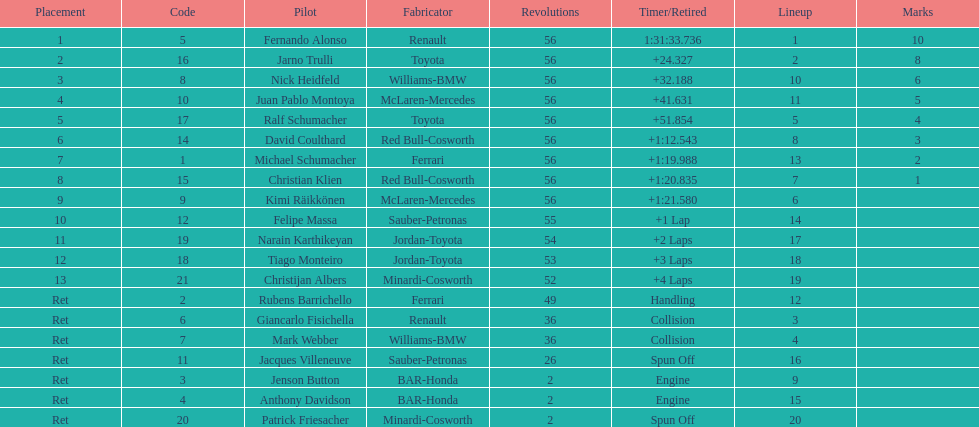How many bmws finished before webber? 1. 